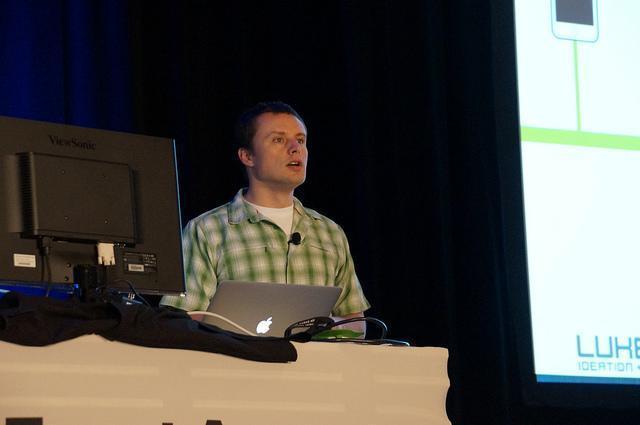How many microphones do you see?
Give a very brief answer. 1. How many tvs are there?
Give a very brief answer. 2. 